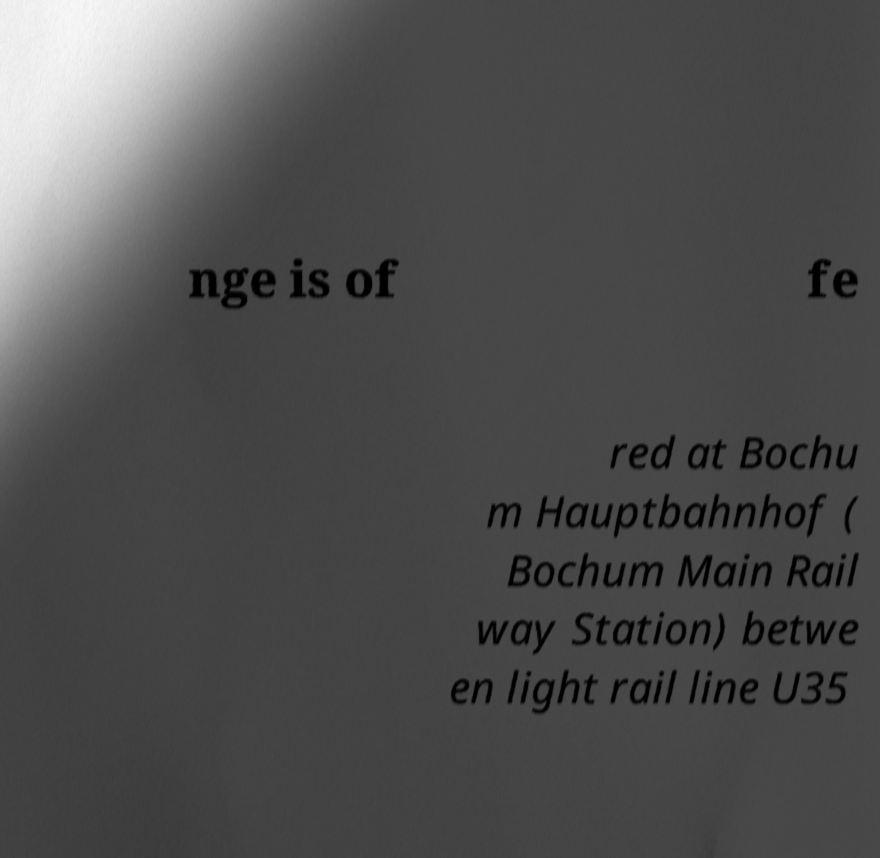What messages or text are displayed in this image? I need them in a readable, typed format. nge is of fe red at Bochu m Hauptbahnhof ( Bochum Main Rail way Station) betwe en light rail line U35 